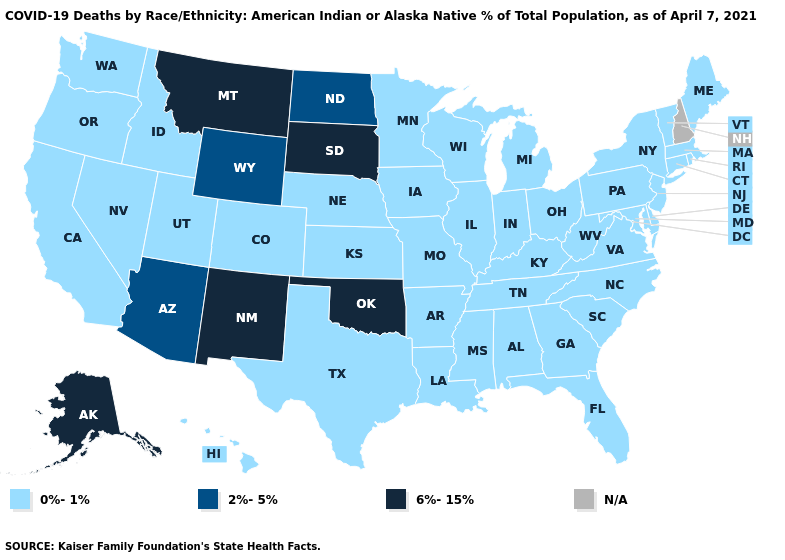Among the states that border Oklahoma , which have the highest value?
Be succinct. New Mexico. How many symbols are there in the legend?
Concise answer only. 4. What is the value of Montana?
Write a very short answer. 6%-15%. Name the states that have a value in the range 2%-5%?
Quick response, please. Arizona, North Dakota, Wyoming. Which states have the highest value in the USA?
Short answer required. Alaska, Montana, New Mexico, Oklahoma, South Dakota. Does Oklahoma have the highest value in the USA?
Be succinct. Yes. What is the value of Massachusetts?
Keep it brief. 0%-1%. Name the states that have a value in the range 2%-5%?
Be succinct. Arizona, North Dakota, Wyoming. Among the states that border Washington , which have the highest value?
Answer briefly. Idaho, Oregon. Does the first symbol in the legend represent the smallest category?
Give a very brief answer. Yes. Name the states that have a value in the range 2%-5%?
Quick response, please. Arizona, North Dakota, Wyoming. Name the states that have a value in the range 2%-5%?
Short answer required. Arizona, North Dakota, Wyoming. Name the states that have a value in the range N/A?
Be succinct. New Hampshire. 